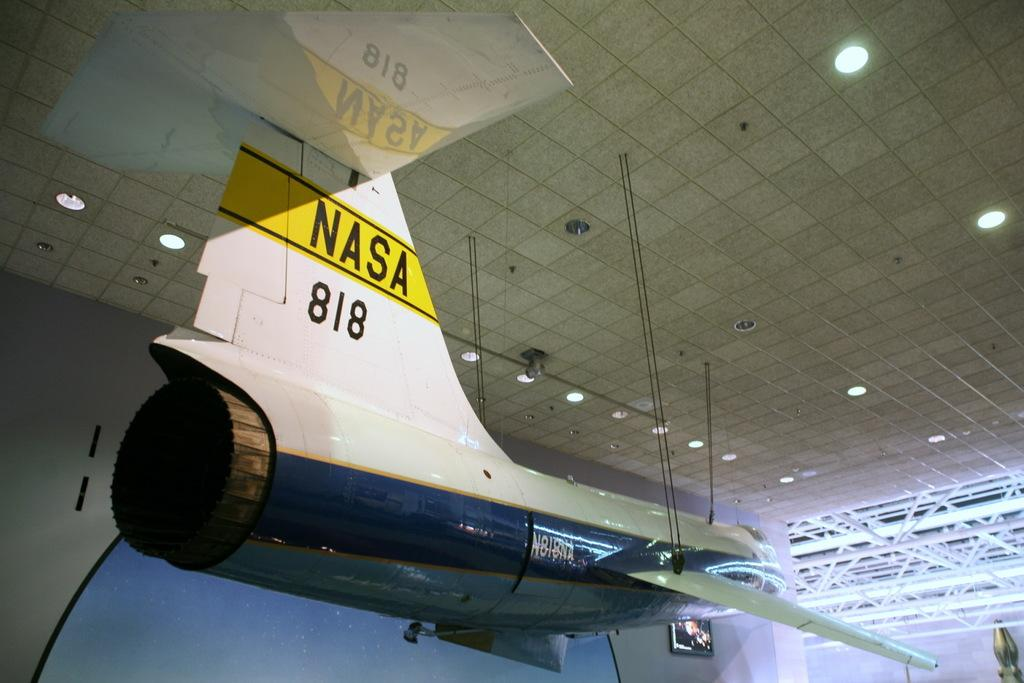Provide a one-sentence caption for the provided image. a NASA 818 shuttle is hanging from the ceiling. 